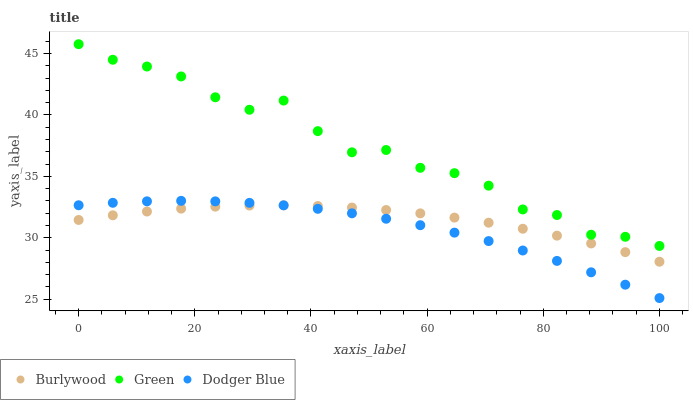Does Dodger Blue have the minimum area under the curve?
Answer yes or no. Yes. Does Green have the maximum area under the curve?
Answer yes or no. Yes. Does Green have the minimum area under the curve?
Answer yes or no. No. Does Dodger Blue have the maximum area under the curve?
Answer yes or no. No. Is Burlywood the smoothest?
Answer yes or no. Yes. Is Green the roughest?
Answer yes or no. Yes. Is Dodger Blue the smoothest?
Answer yes or no. No. Is Dodger Blue the roughest?
Answer yes or no. No. Does Dodger Blue have the lowest value?
Answer yes or no. Yes. Does Green have the lowest value?
Answer yes or no. No. Does Green have the highest value?
Answer yes or no. Yes. Does Dodger Blue have the highest value?
Answer yes or no. No. Is Burlywood less than Green?
Answer yes or no. Yes. Is Green greater than Burlywood?
Answer yes or no. Yes. Does Burlywood intersect Dodger Blue?
Answer yes or no. Yes. Is Burlywood less than Dodger Blue?
Answer yes or no. No. Is Burlywood greater than Dodger Blue?
Answer yes or no. No. Does Burlywood intersect Green?
Answer yes or no. No. 